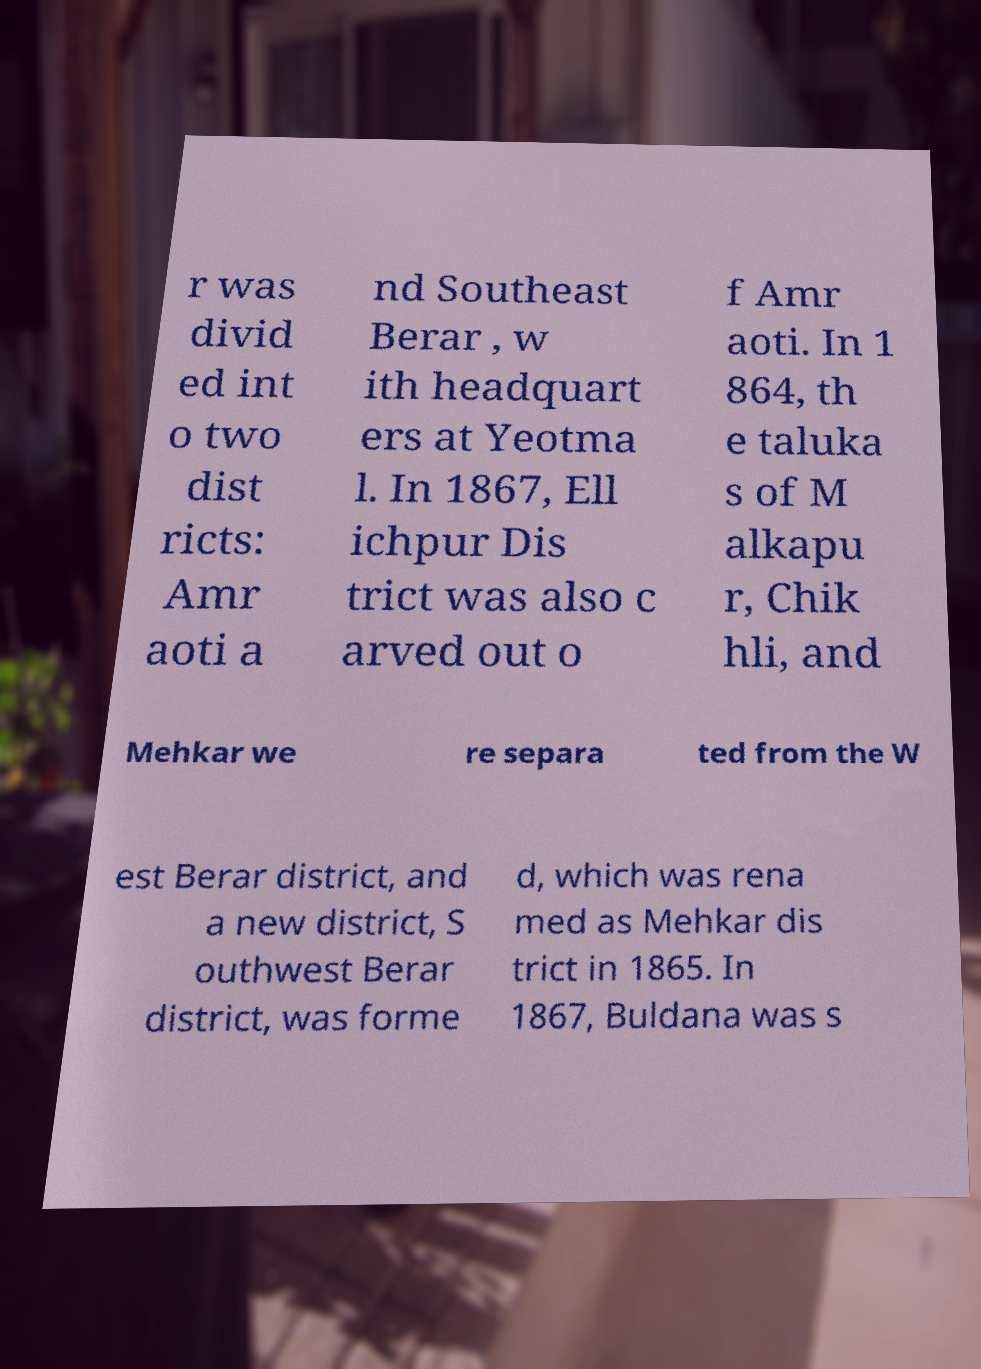I need the written content from this picture converted into text. Can you do that? r was divid ed int o two dist ricts: Amr aoti a nd Southeast Berar , w ith headquart ers at Yeotma l. In 1867, Ell ichpur Dis trict was also c arved out o f Amr aoti. In 1 864, th e taluka s of M alkapu r, Chik hli, and Mehkar we re separa ted from the W est Berar district, and a new district, S outhwest Berar district, was forme d, which was rena med as Mehkar dis trict in 1865. In 1867, Buldana was s 